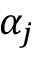<formula> <loc_0><loc_0><loc_500><loc_500>\alpha _ { j }</formula> 